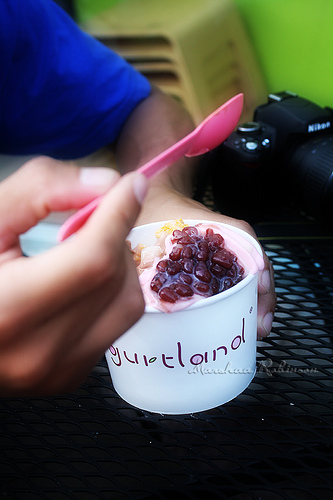<image>
Can you confirm if the spoon is behind the cup? No. The spoon is not behind the cup. From this viewpoint, the spoon appears to be positioned elsewhere in the scene. 